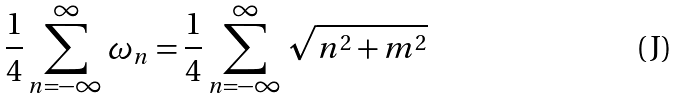<formula> <loc_0><loc_0><loc_500><loc_500>\frac { 1 } { 4 } \sum _ { n = - \infty } ^ { \infty } \omega _ { n } = \frac { 1 } { 4 } \sum _ { n = - \infty } ^ { \infty } \sqrt { n ^ { 2 } + m ^ { 2 } }</formula> 